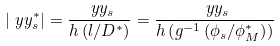<formula> <loc_0><loc_0><loc_500><loc_500>| \ y y _ { s } ^ { * } | = \frac { \ y y _ { s } } { h \left ( l / D ^ { * } \right ) } = \frac { \ y y _ { s } } { h \left ( g ^ { - 1 } \left ( \phi _ { s } / \phi _ { M } ^ { * } \right ) \right ) }</formula> 